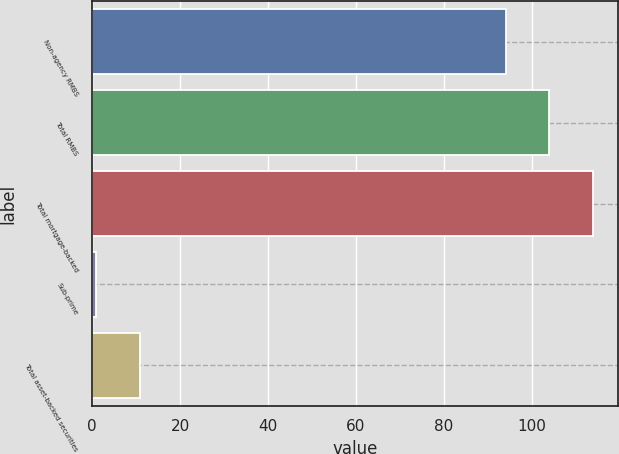Convert chart to OTSL. <chart><loc_0><loc_0><loc_500><loc_500><bar_chart><fcel>Non-agency RMBS<fcel>Total RMBS<fcel>Total mortgage-backed<fcel>Sub-prime<fcel>Total asset-backed securities<nl><fcel>94<fcel>103.9<fcel>113.8<fcel>1<fcel>10.9<nl></chart> 